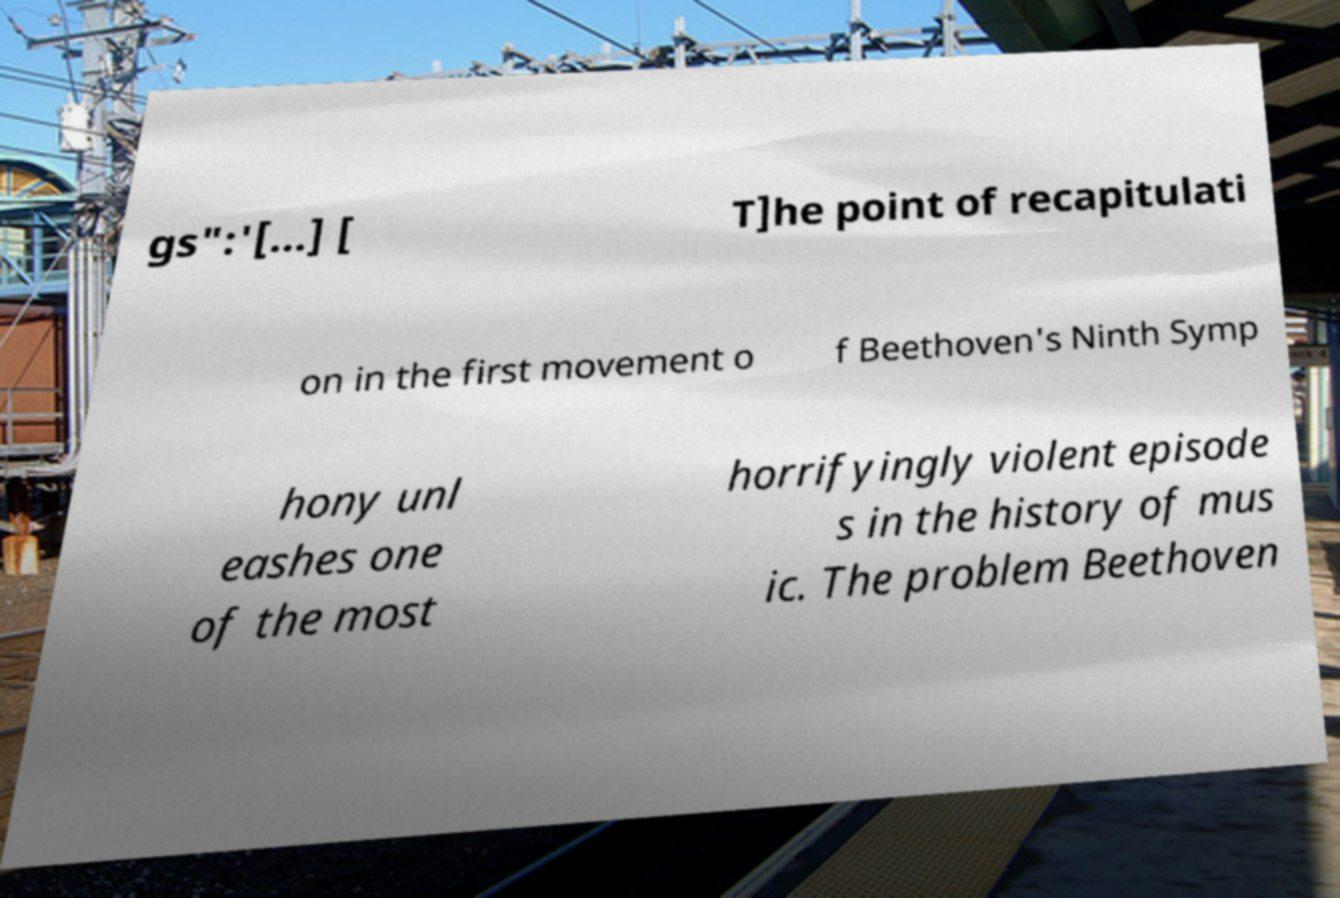Could you extract and type out the text from this image? gs":'[...] [ T]he point of recapitulati on in the first movement o f Beethoven's Ninth Symp hony unl eashes one of the most horrifyingly violent episode s in the history of mus ic. The problem Beethoven 